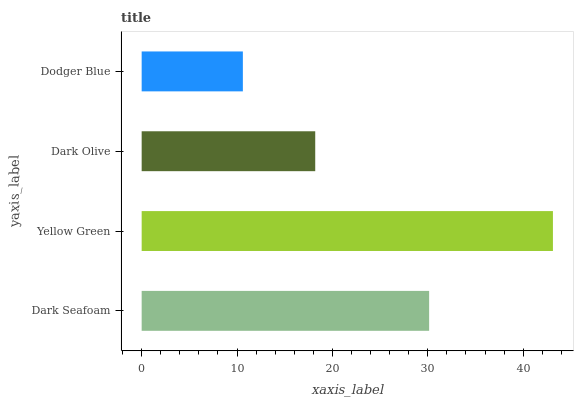Is Dodger Blue the minimum?
Answer yes or no. Yes. Is Yellow Green the maximum?
Answer yes or no. Yes. Is Dark Olive the minimum?
Answer yes or no. No. Is Dark Olive the maximum?
Answer yes or no. No. Is Yellow Green greater than Dark Olive?
Answer yes or no. Yes. Is Dark Olive less than Yellow Green?
Answer yes or no. Yes. Is Dark Olive greater than Yellow Green?
Answer yes or no. No. Is Yellow Green less than Dark Olive?
Answer yes or no. No. Is Dark Seafoam the high median?
Answer yes or no. Yes. Is Dark Olive the low median?
Answer yes or no. Yes. Is Yellow Green the high median?
Answer yes or no. No. Is Yellow Green the low median?
Answer yes or no. No. 